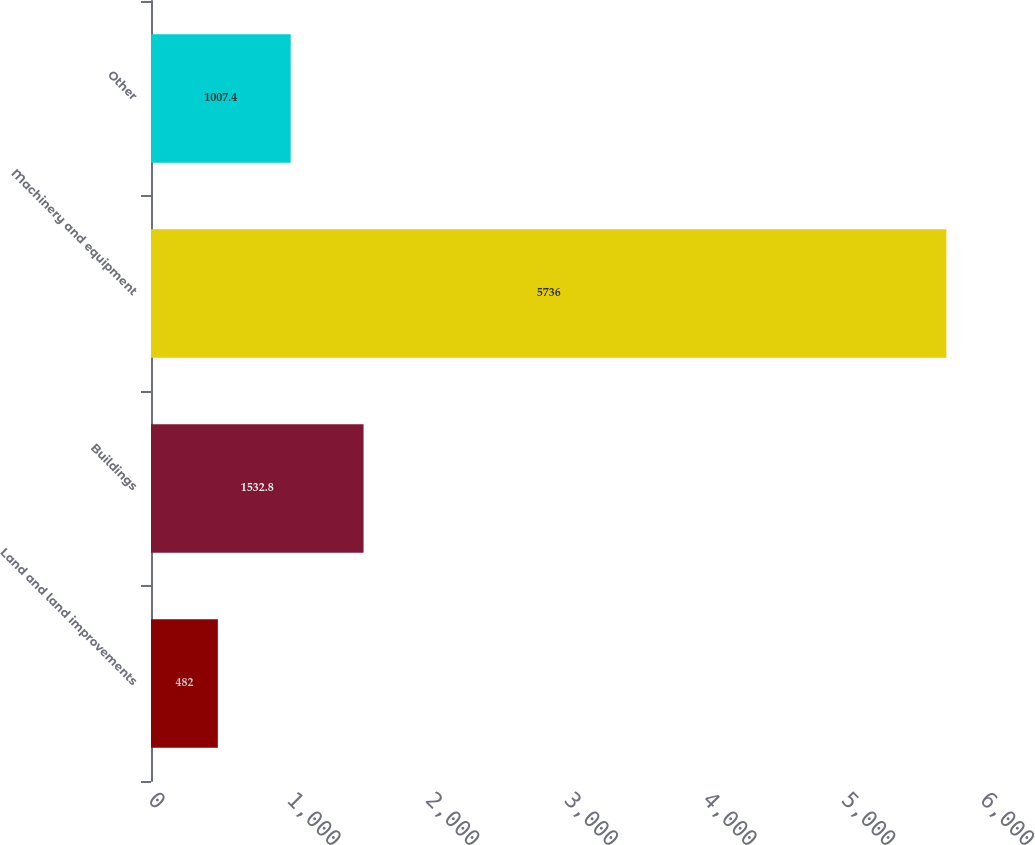Convert chart to OTSL. <chart><loc_0><loc_0><loc_500><loc_500><bar_chart><fcel>Land and land improvements<fcel>Buildings<fcel>Machinery and equipment<fcel>Other<nl><fcel>482<fcel>1532.8<fcel>5736<fcel>1007.4<nl></chart> 